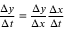<formula> <loc_0><loc_0><loc_500><loc_500>{ \frac { \Delta y } { \Delta t } } = { \frac { \Delta y } { \Delta x } } { \frac { \Delta x } { \Delta t } }</formula> 